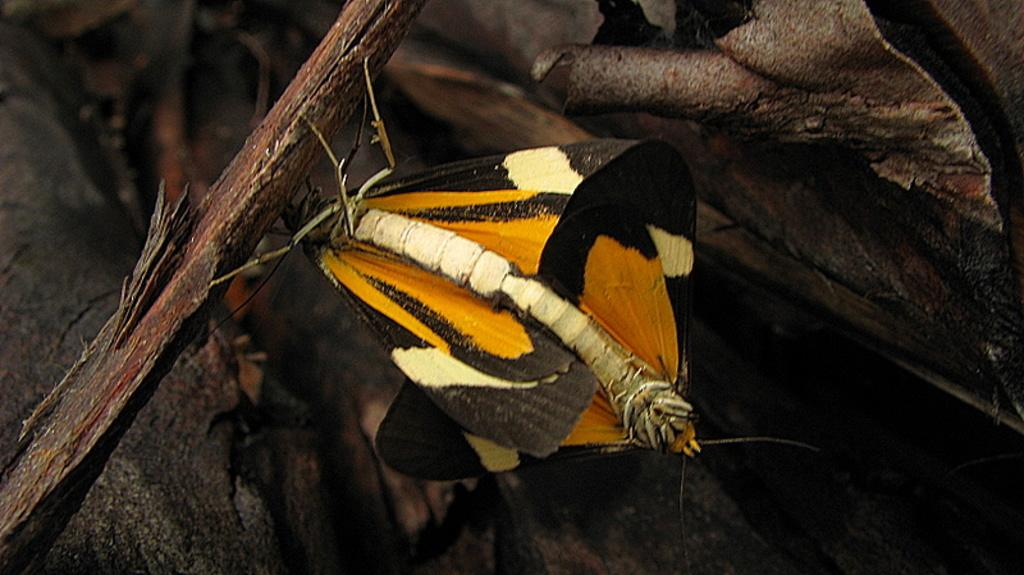What can be seen in the foreground of the picture? In the foreground of the picture, there are insects, a tree trunk, and other objects. Can you describe the insects in the picture? A: The insects are visible in the foreground of the picture, but their specific type or characteristics are not mentioned in the provided facts. What else is present in the foreground of the picture besides the insects and tree trunk? There are other objects in the foreground of the picture, but their nature is not specified in the provided facts. What can be said about the background of the image? The background of the image is not clear, as mentioned in the provided facts. What type of music is playing in the background of the image? There is no mention of music or any sound in the provided facts, so it cannot be determined from the image. What rate of speed are the insects moving at in the image? The provided facts do not mention the speed or movement of the insects, so it cannot be determined from the image. 